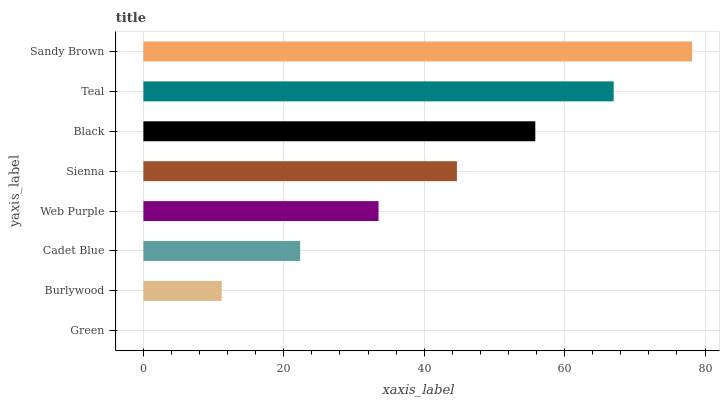Is Green the minimum?
Answer yes or no. Yes. Is Sandy Brown the maximum?
Answer yes or no. Yes. Is Burlywood the minimum?
Answer yes or no. No. Is Burlywood the maximum?
Answer yes or no. No. Is Burlywood greater than Green?
Answer yes or no. Yes. Is Green less than Burlywood?
Answer yes or no. Yes. Is Green greater than Burlywood?
Answer yes or no. No. Is Burlywood less than Green?
Answer yes or no. No. Is Sienna the high median?
Answer yes or no. Yes. Is Web Purple the low median?
Answer yes or no. Yes. Is Teal the high median?
Answer yes or no. No. Is Burlywood the low median?
Answer yes or no. No. 